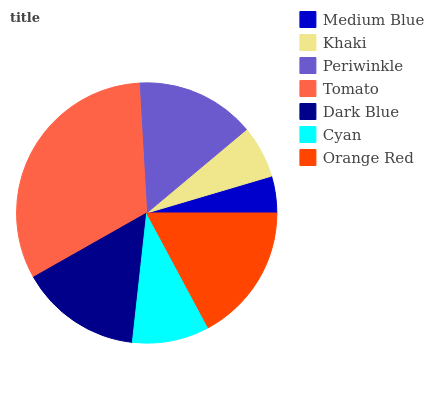Is Medium Blue the minimum?
Answer yes or no. Yes. Is Tomato the maximum?
Answer yes or no. Yes. Is Khaki the minimum?
Answer yes or no. No. Is Khaki the maximum?
Answer yes or no. No. Is Khaki greater than Medium Blue?
Answer yes or no. Yes. Is Medium Blue less than Khaki?
Answer yes or no. Yes. Is Medium Blue greater than Khaki?
Answer yes or no. No. Is Khaki less than Medium Blue?
Answer yes or no. No. Is Periwinkle the high median?
Answer yes or no. Yes. Is Periwinkle the low median?
Answer yes or no. Yes. Is Medium Blue the high median?
Answer yes or no. No. Is Tomato the low median?
Answer yes or no. No. 